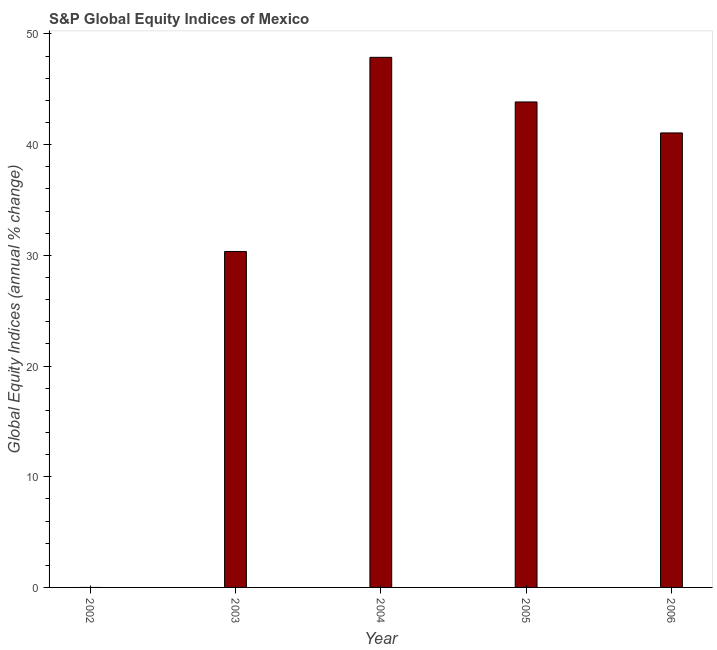Does the graph contain grids?
Offer a terse response. No. What is the title of the graph?
Keep it short and to the point. S&P Global Equity Indices of Mexico. What is the label or title of the X-axis?
Make the answer very short. Year. What is the label or title of the Y-axis?
Ensure brevity in your answer.  Global Equity Indices (annual % change). What is the s&p global equity indices in 2006?
Offer a terse response. 41.06. Across all years, what is the maximum s&p global equity indices?
Provide a succinct answer. 47.89. What is the sum of the s&p global equity indices?
Your answer should be very brief. 163.16. What is the difference between the s&p global equity indices in 2004 and 2006?
Offer a very short reply. 6.83. What is the average s&p global equity indices per year?
Give a very brief answer. 32.63. What is the median s&p global equity indices?
Offer a terse response. 41.06. What is the ratio of the s&p global equity indices in 2003 to that in 2006?
Give a very brief answer. 0.74. Is the difference between the s&p global equity indices in 2003 and 2004 greater than the difference between any two years?
Make the answer very short. No. What is the difference between the highest and the second highest s&p global equity indices?
Ensure brevity in your answer.  4.03. What is the difference between the highest and the lowest s&p global equity indices?
Ensure brevity in your answer.  47.89. In how many years, is the s&p global equity indices greater than the average s&p global equity indices taken over all years?
Your response must be concise. 3. How many bars are there?
Keep it short and to the point. 4. Are all the bars in the graph horizontal?
Give a very brief answer. No. How many years are there in the graph?
Keep it short and to the point. 5. Are the values on the major ticks of Y-axis written in scientific E-notation?
Your answer should be very brief. No. What is the Global Equity Indices (annual % change) in 2003?
Your answer should be compact. 30.35. What is the Global Equity Indices (annual % change) of 2004?
Provide a succinct answer. 47.89. What is the Global Equity Indices (annual % change) in 2005?
Offer a terse response. 43.86. What is the Global Equity Indices (annual % change) in 2006?
Offer a very short reply. 41.06. What is the difference between the Global Equity Indices (annual % change) in 2003 and 2004?
Keep it short and to the point. -17.54. What is the difference between the Global Equity Indices (annual % change) in 2003 and 2005?
Provide a short and direct response. -13.51. What is the difference between the Global Equity Indices (annual % change) in 2003 and 2006?
Offer a very short reply. -10.71. What is the difference between the Global Equity Indices (annual % change) in 2004 and 2005?
Provide a succinct answer. 4.03. What is the difference between the Global Equity Indices (annual % change) in 2004 and 2006?
Your answer should be very brief. 6.83. What is the difference between the Global Equity Indices (annual % change) in 2005 and 2006?
Keep it short and to the point. 2.8. What is the ratio of the Global Equity Indices (annual % change) in 2003 to that in 2004?
Make the answer very short. 0.63. What is the ratio of the Global Equity Indices (annual % change) in 2003 to that in 2005?
Your answer should be very brief. 0.69. What is the ratio of the Global Equity Indices (annual % change) in 2003 to that in 2006?
Offer a terse response. 0.74. What is the ratio of the Global Equity Indices (annual % change) in 2004 to that in 2005?
Keep it short and to the point. 1.09. What is the ratio of the Global Equity Indices (annual % change) in 2004 to that in 2006?
Offer a very short reply. 1.17. What is the ratio of the Global Equity Indices (annual % change) in 2005 to that in 2006?
Provide a succinct answer. 1.07. 